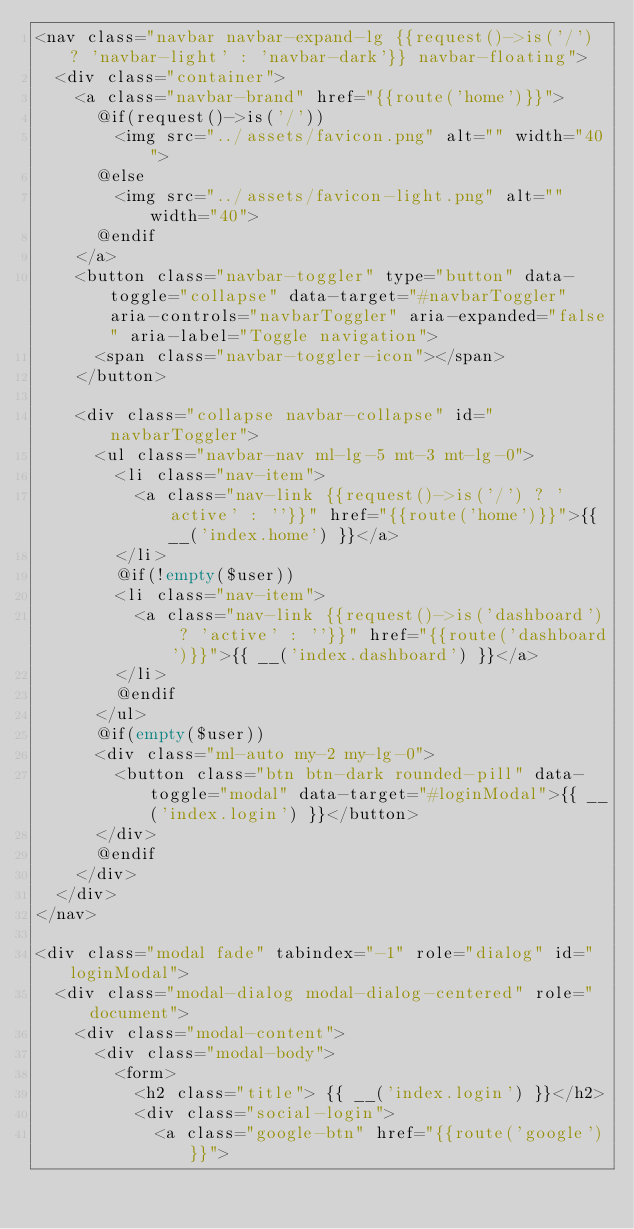<code> <loc_0><loc_0><loc_500><loc_500><_PHP_><nav class="navbar navbar-expand-lg {{request()->is('/') ? 'navbar-light' : 'navbar-dark'}} navbar-floating">
  <div class="container">
    <a class="navbar-brand" href="{{route('home')}}">
      @if(request()->is('/'))
        <img src="../assets/favicon.png" alt="" width="40">
      @else
        <img src="../assets/favicon-light.png" alt="" width="40">
      @endif
    </a>
    <button class="navbar-toggler" type="button" data-toggle="collapse" data-target="#navbarToggler" aria-controls="navbarToggler" aria-expanded="false" aria-label="Toggle navigation">
      <span class="navbar-toggler-icon"></span>
    </button>

    <div class="collapse navbar-collapse" id="navbarToggler">
      <ul class="navbar-nav ml-lg-5 mt-3 mt-lg-0">
        <li class="nav-item">
          <a class="nav-link {{request()->is('/') ? 'active' : ''}}" href="{{route('home')}}">{{ __('index.home') }}</a>
        </li>
        @if(!empty($user))
        <li class="nav-item">
          <a class="nav-link {{request()->is('dashboard') ? 'active' : ''}}" href="{{route('dashboard')}}">{{ __('index.dashboard') }}</a>
        </li>
        @endif
      </ul>
      @if(empty($user))
      <div class="ml-auto my-2 my-lg-0">
        <button class="btn btn-dark rounded-pill" data-toggle="modal" data-target="#loginModal">{{ __('index.login') }}</button>
      </div>
      @endif
    </div>
  </div>
</nav>

<div class="modal fade" tabindex="-1" role="dialog" id="loginModal">
  <div class="modal-dialog modal-dialog-centered" role="document">
    <div class="modal-content">
      <div class="modal-body">
        <form>
          <h2 class="title"> {{ __('index.login') }}</h2>
          <div class="social-login">
            <a class="google-btn" href="{{route('google')}}"></code> 